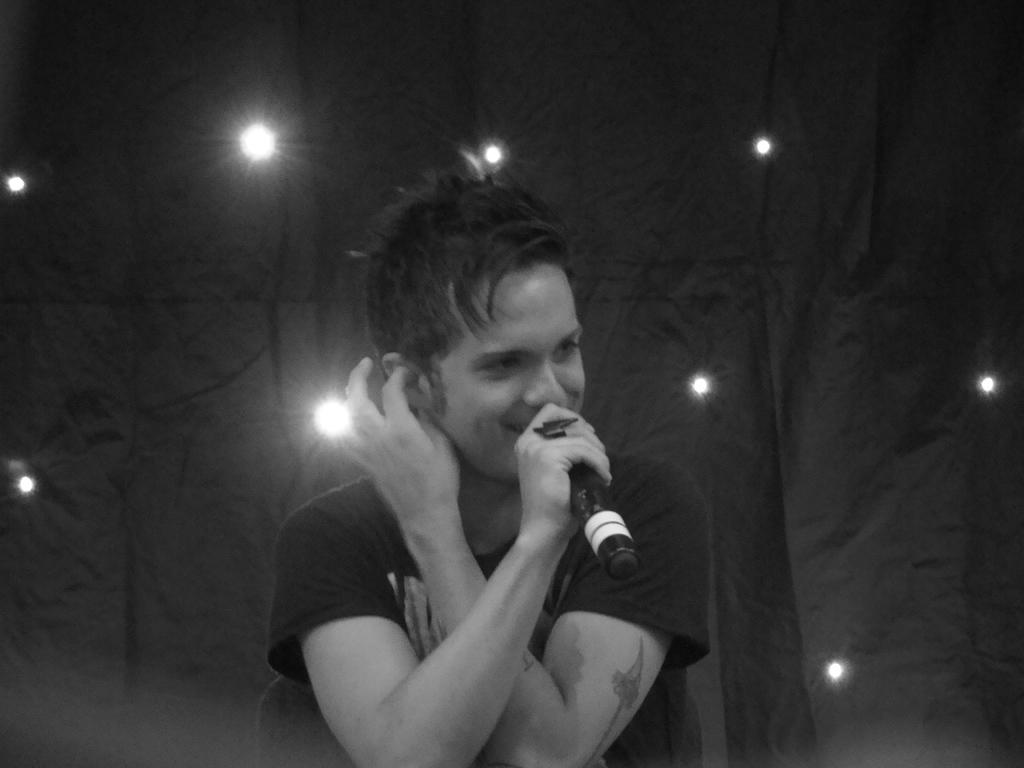Who is the main subject in the picture? There is a boy in the picture. What is the boy holding in his hands? The boy is holding a mic in his hands. What can be seen in the background of the image? There is a cloth and lights in the background of the image. Can you tell me how many people are involved in the fight in the image? There is no fight present in the image; it features a boy holding a mic. What type of ship can be seen sailing in the background of the image? There is no ship present in the image; it only shows a boy holding a mic, a cloth, and lights in the background. 